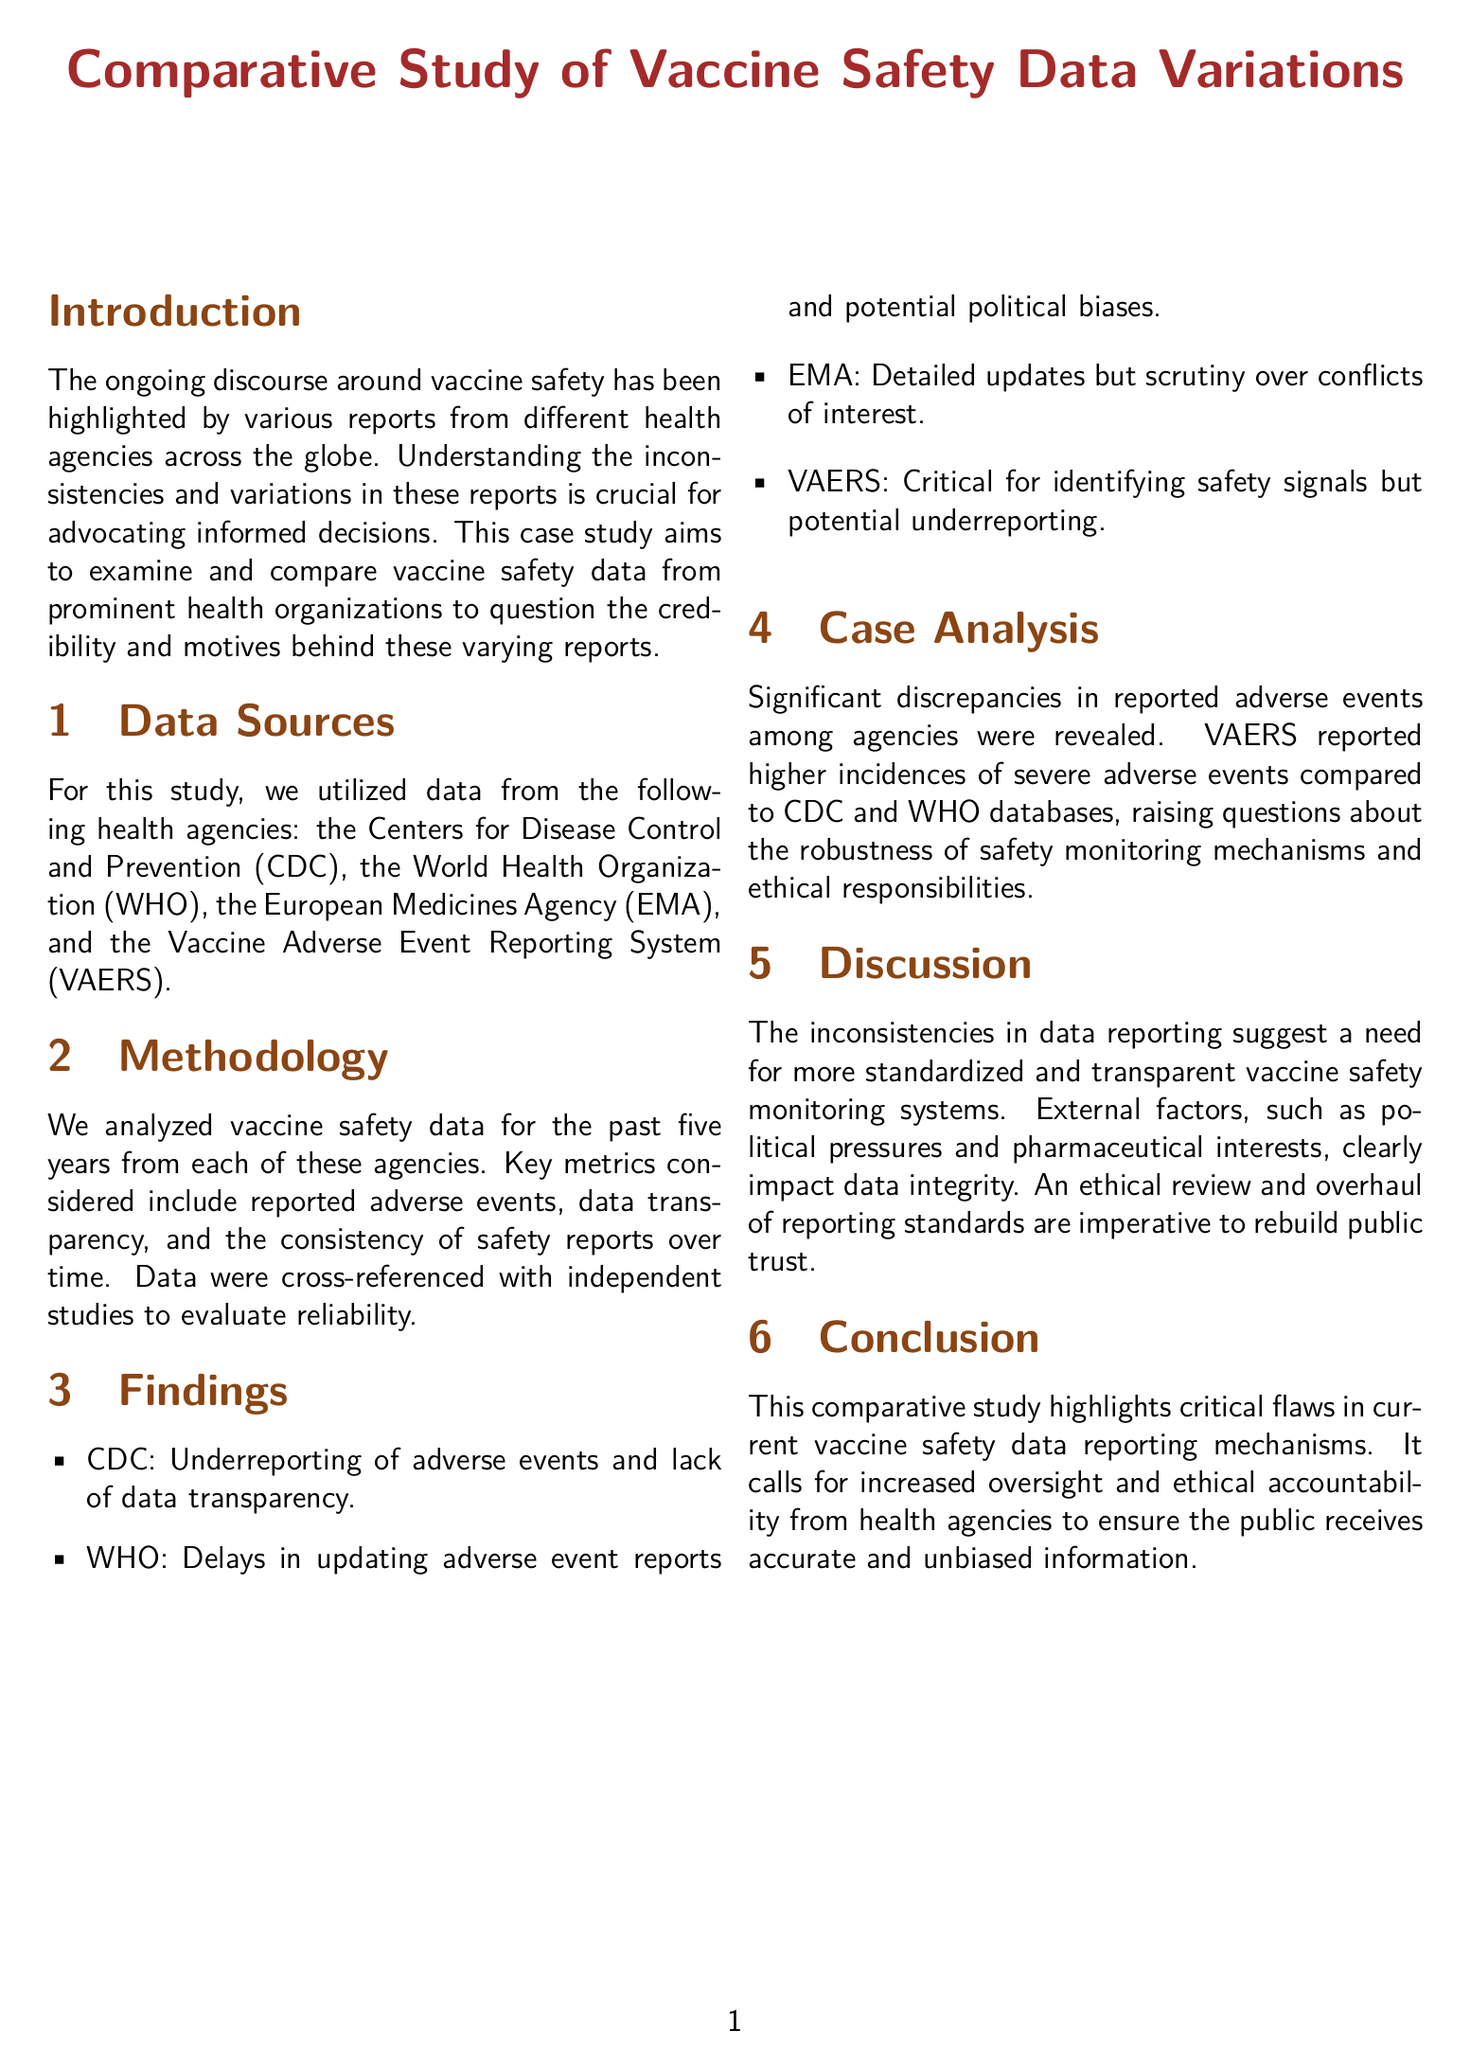What are the data sources used in the study? The study utilized data from the CDC, WHO, EMA, and VAERS.
Answer: CDC, WHO, EMA, VAERS What key metrics were analyzed in the study? Key metrics considered include reported adverse events, data transparency, and the consistency of safety reports over time.
Answer: Adverse events, data transparency, consistency Which agency reported underreporting of adverse events? The CDC was noted for underreporting adverse events and lack of data transparency.
Answer: CDC What was a major finding related to VAERS? VAERS reported higher incidences of severe adverse events compared to CDC and WHO databases.
Answer: Higher incidences What does the discussion suggest is needed for vaccine safety monitoring? The discussion suggests a need for more standardized and transparent vaccine safety monitoring systems.
Answer: Standardized and transparent systems How many years of data were analyzed for this study? The study analyzed vaccine safety data for the past five years.
Answer: Five years What impact do political pressures have according to the document? Political pressures impact data integrity in vaccine safety reporting.
Answer: Data integrity What is the call to action in the conclusion? The conclusion calls for increased oversight and ethical accountability from health agencies.
Answer: Increased oversight and accountability 